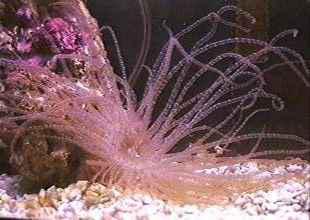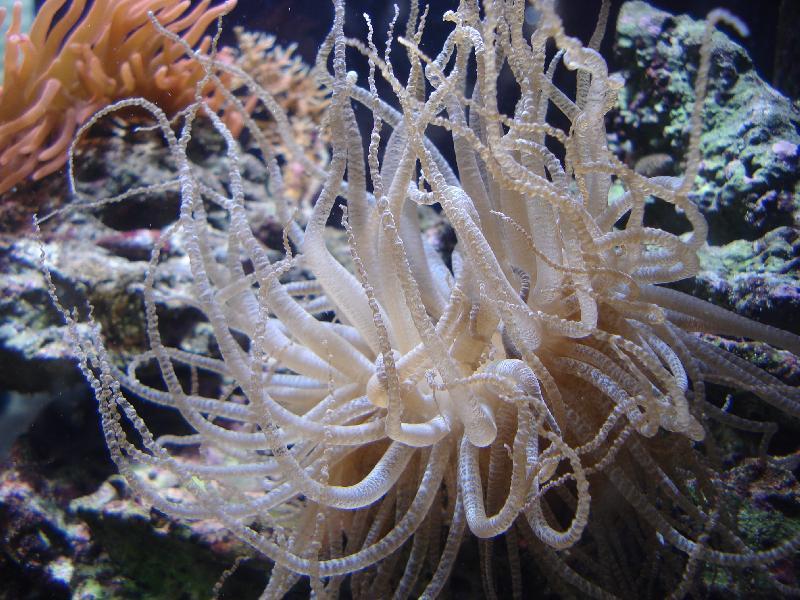The first image is the image on the left, the second image is the image on the right. Given the left and right images, does the statement "One image shows a flower-look anemone with tapering tendrils around a flat center, and the other shows one large anemone with densely-packed neutral-colored tendrils." hold true? Answer yes or no. No. 